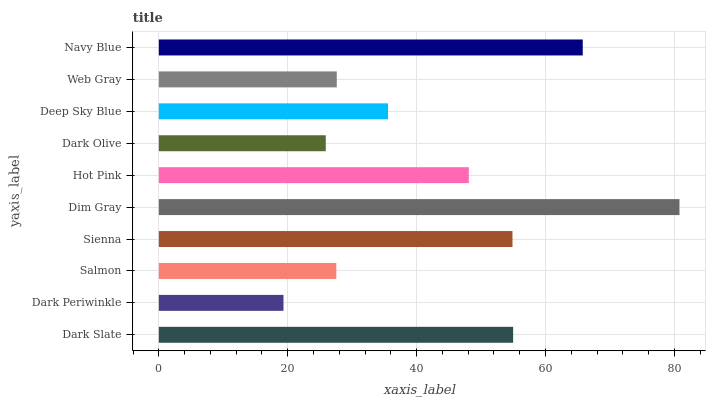Is Dark Periwinkle the minimum?
Answer yes or no. Yes. Is Dim Gray the maximum?
Answer yes or no. Yes. Is Salmon the minimum?
Answer yes or no. No. Is Salmon the maximum?
Answer yes or no. No. Is Salmon greater than Dark Periwinkle?
Answer yes or no. Yes. Is Dark Periwinkle less than Salmon?
Answer yes or no. Yes. Is Dark Periwinkle greater than Salmon?
Answer yes or no. No. Is Salmon less than Dark Periwinkle?
Answer yes or no. No. Is Hot Pink the high median?
Answer yes or no. Yes. Is Deep Sky Blue the low median?
Answer yes or no. Yes. Is Navy Blue the high median?
Answer yes or no. No. Is Navy Blue the low median?
Answer yes or no. No. 